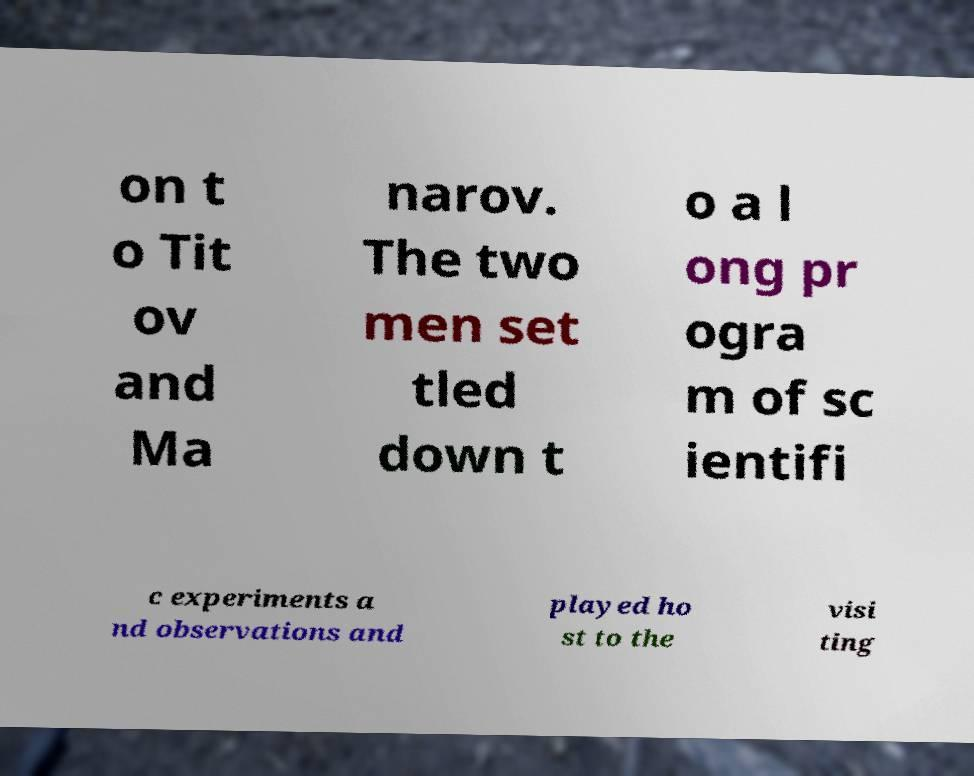Please identify and transcribe the text found in this image. on t o Tit ov and Ma narov. The two men set tled down t o a l ong pr ogra m of sc ientifi c experiments a nd observations and played ho st to the visi ting 